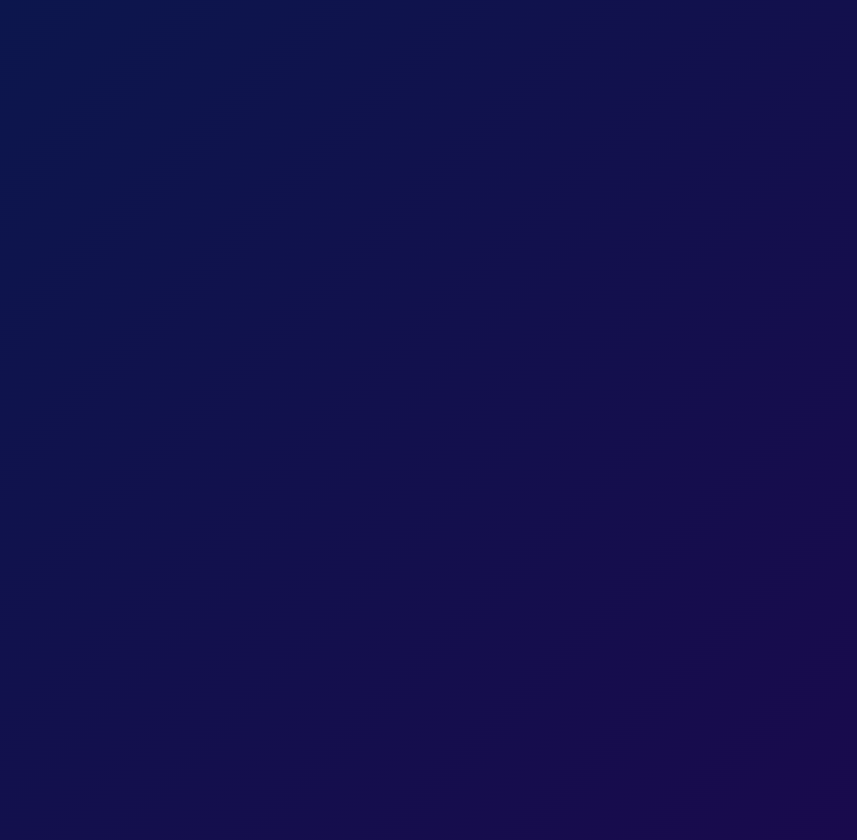What is the title of the card? The title is presented prominently on the front of the card.
Answer: Cosmic Cuisine Congratulations! What cooking techniques were utilized in the experiment? The document specifies two advanced techniques used in the cooking experiment.
Answer: vacuum-packing and sous-vide What is the significance of the cooking experiment? The document explains how this experiment enhances life for astronauts during missions.
Answer: enhances the quality of life aboard long-duration space missions What is the potential impact of the successful experiment? The document mentions a specific upcoming mission where this progress is particularly important.
Answer: missions to Mars What role will the findings from this experiment play in the International Space Station? The document describes how the expertise from the experiment can influence a certain program.
Answer: food program What does the footer of the card convey? The footer contains a final congratulatory message reflecting the overall tone of the card.
Answer: culinary adventures beyond our home planet How many stars animate on the card's front? The script in the document suggests a specific number of stars that twinkle on the card.
Answer: 50 What themes are primarily highlighted in the card? The card emphasizes various themes regarding space cooking and its implications.
Answer: culinary skills and space exploration 